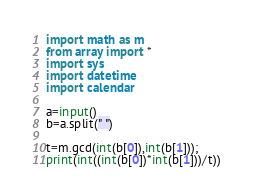<code> <loc_0><loc_0><loc_500><loc_500><_Python_>import math as m
from array import *
import sys
import datetime
import calendar

a=input()
b=a.split(" ")

t=m.gcd(int(b[0]),int(b[1]));
print(int((int(b[0])*int(b[1]))/t))
</code> 